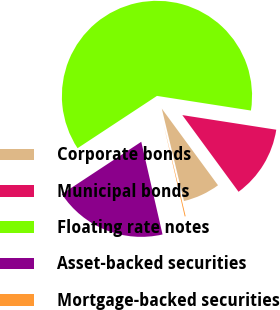Convert chart to OTSL. <chart><loc_0><loc_0><loc_500><loc_500><pie_chart><fcel>Corporate bonds<fcel>Municipal bonds<fcel>Floating rate notes<fcel>Asset-backed securities<fcel>Mortgage-backed securities<nl><fcel>6.32%<fcel>12.47%<fcel>61.72%<fcel>19.32%<fcel>0.16%<nl></chart> 